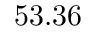<formula> <loc_0><loc_0><loc_500><loc_500>5 3 . 3 6</formula> 